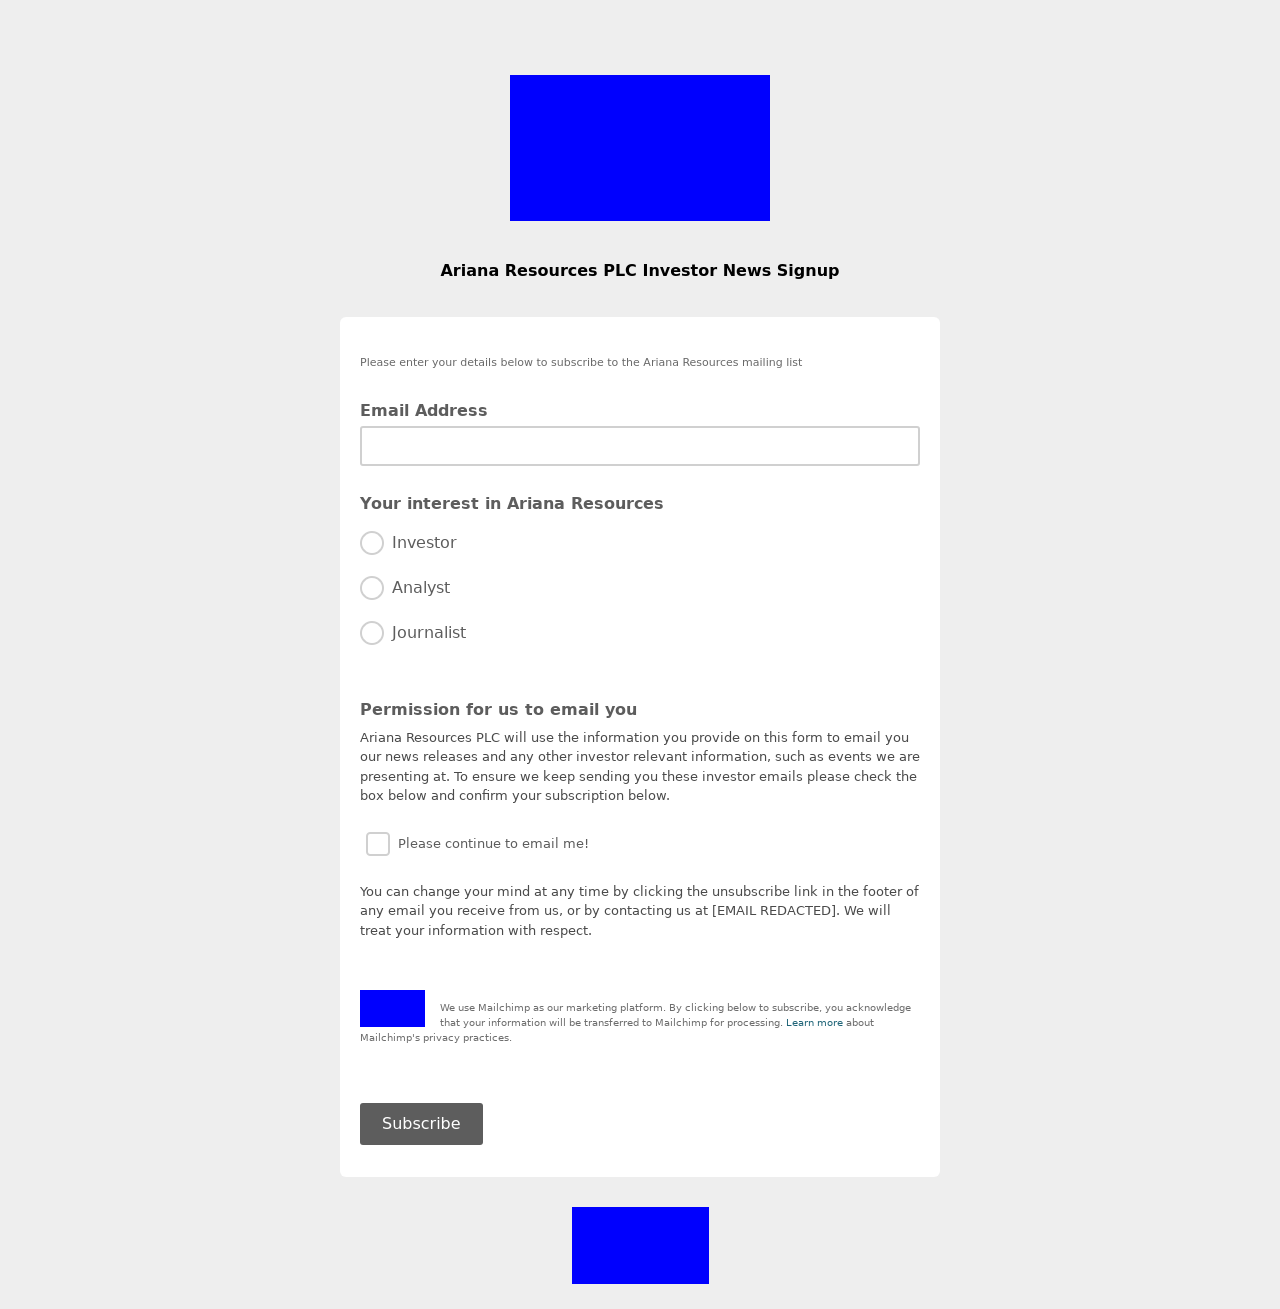What are the privacy implications of using third-party services like Mailchimp as highlighted in the footer? Using third-party services like Mailchimp involves transferring and storing personal data on their servers. While they offer convenience and robust features for managing email marketing campaigns, it is essential to understand their privacy practices. They typically implement security measures to protect your data but reading their privacy policy will provide a clearer understanding of how your information is handled, including data retention, security measures, and rights you have regarding your data. Always ensure their compliance with regulations like GDPR if you are handling data from EU citizens. 